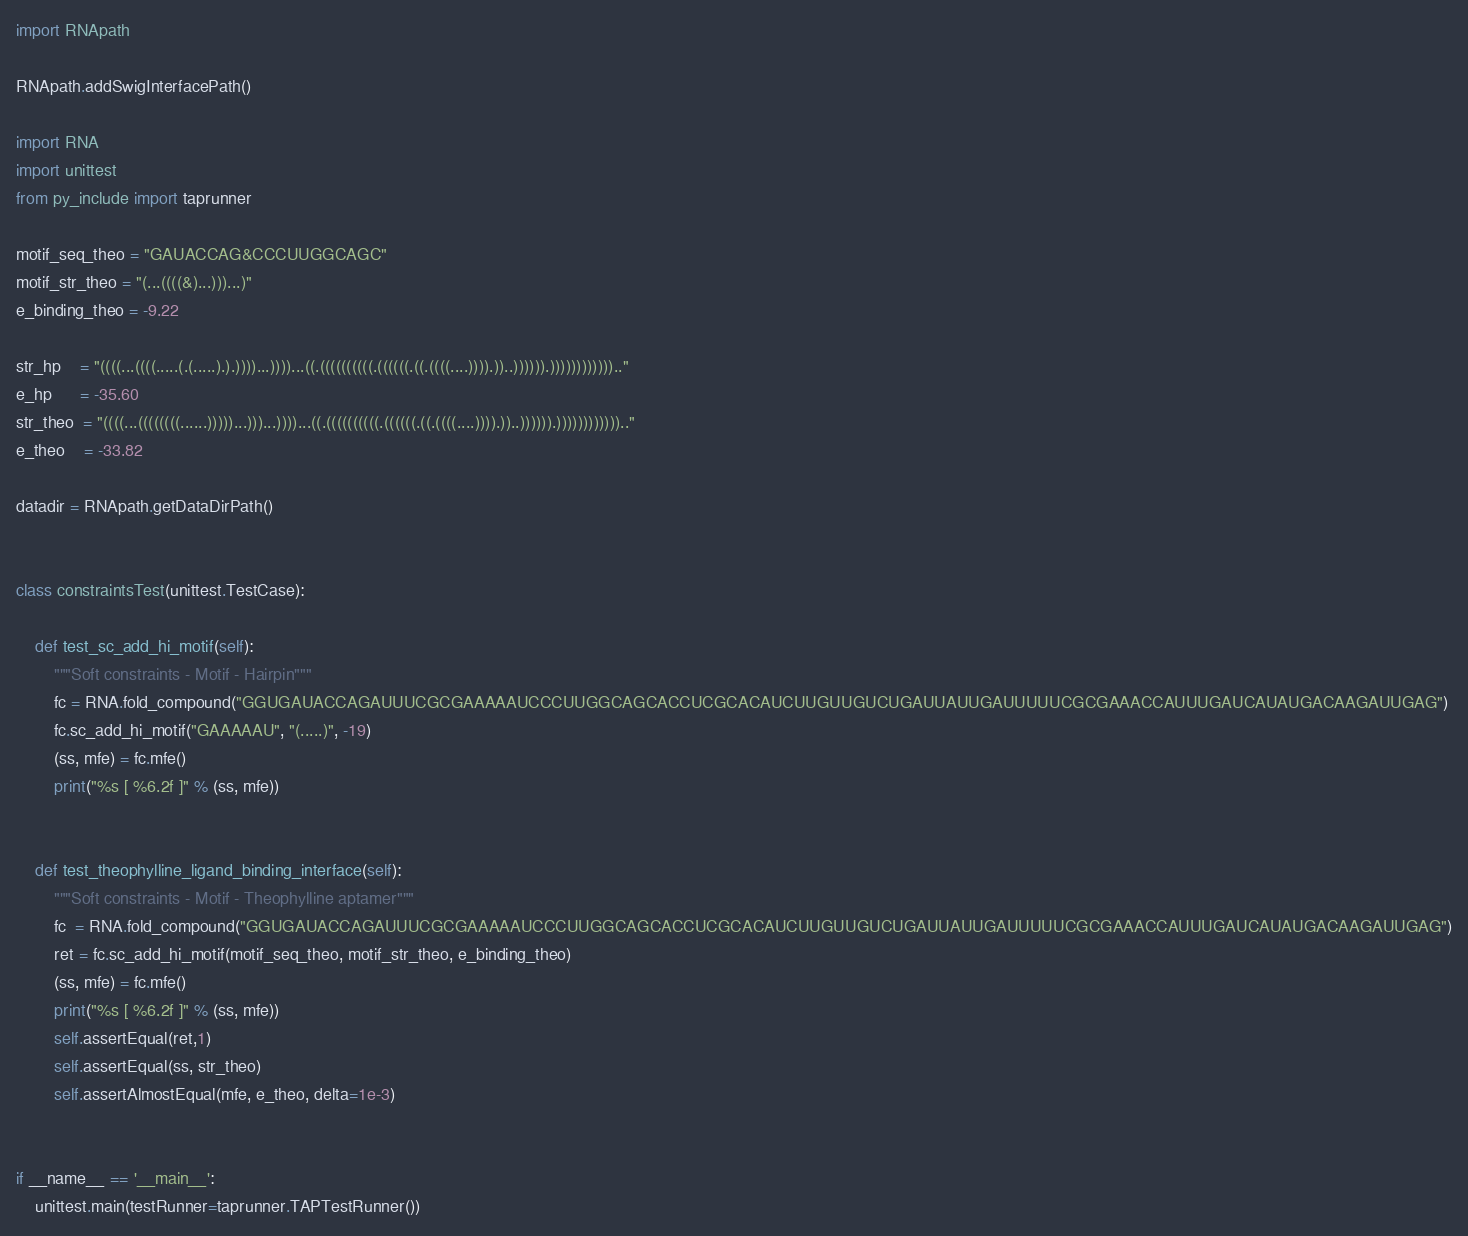<code> <loc_0><loc_0><loc_500><loc_500><_Python_>import RNApath

RNApath.addSwigInterfacePath()

import RNA
import unittest
from py_include import taprunner

motif_seq_theo = "GAUACCAG&CCCUUGGCAGC"
motif_str_theo = "(...((((&)...)))...)"
e_binding_theo = -9.22

str_hp    = "((((...((((.....(.(.....).).))))...))))...((.((((((((((.((((((.((.((((....)))).))..)))))).)))))))))))).."
e_hp      = -35.60
str_theo  = "((((...((((((((......)))))...)))...))))...((.((((((((((.((((((.((.((((....)))).))..)))))).)))))))))))).."
e_theo    = -33.82

datadir = RNApath.getDataDirPath()


class constraintsTest(unittest.TestCase):

    def test_sc_add_hi_motif(self):
        """Soft constraints - Motif - Hairpin"""
        fc = RNA.fold_compound("GGUGAUACCAGAUUUCGCGAAAAAUCCCUUGGCAGCACCUCGCACAUCUUGUUGUCUGAUUAUUGAUUUUUCGCGAAACCAUUUGAUCAUAUGACAAGAUUGAG")
        fc.sc_add_hi_motif("GAAAAAU", "(.....)", -19)
        (ss, mfe) = fc.mfe()
        print("%s [ %6.2f ]" % (ss, mfe))


    def test_theophylline_ligand_binding_interface(self):
        """Soft constraints - Motif - Theophylline aptamer"""
        fc  = RNA.fold_compound("GGUGAUACCAGAUUUCGCGAAAAAUCCCUUGGCAGCACCUCGCACAUCUUGUUGUCUGAUUAUUGAUUUUUCGCGAAACCAUUUGAUCAUAUGACAAGAUUGAG")
        ret = fc.sc_add_hi_motif(motif_seq_theo, motif_str_theo, e_binding_theo)
        (ss, mfe) = fc.mfe()
        print("%s [ %6.2f ]" % (ss, mfe))
        self.assertEqual(ret,1)
        self.assertEqual(ss, str_theo)
        self.assertAlmostEqual(mfe, e_theo, delta=1e-3)


if __name__ == '__main__':
    unittest.main(testRunner=taprunner.TAPTestRunner())
</code> 